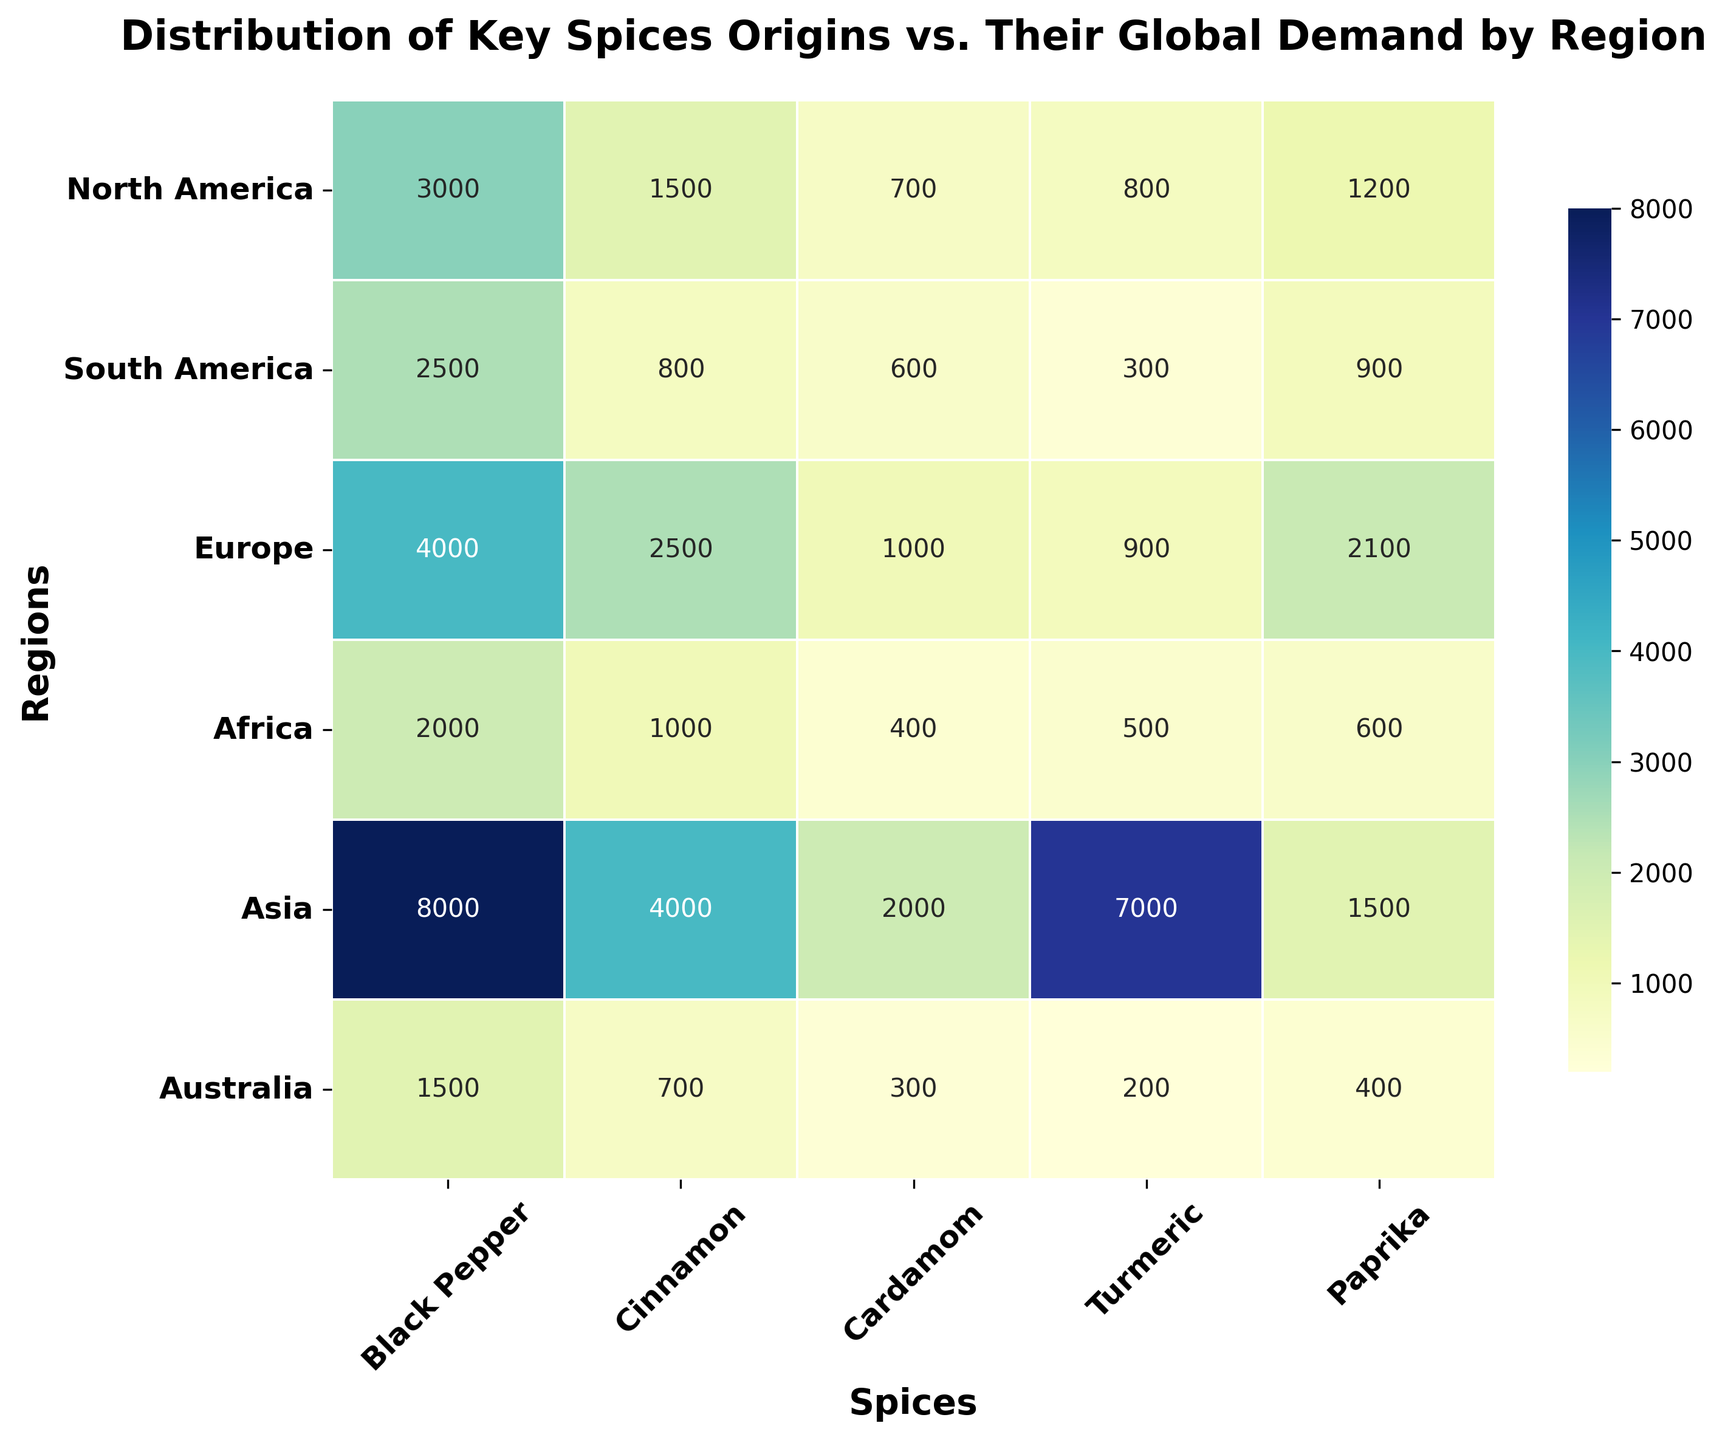which region has the highest global demand for black pepper? By observing the heatmap and looking for the darkest blue (indicating the highest value) in the Black Pepper column, we see that Asia has the darkest blue shade.
Answer: Asia what's the total demand for turmeric in north america and south america combined? Check the values for Turmeric demand in North America and South America: North America = 800, South America = 300. Add the two values: 800 + 300 = 1100.
Answer: 1100 which spice shows the greatest demand in Europe? By examining the Europe row, the highest value is 4000 under Black Pepper. So, Black Pepper shows the greatest demand in Europe.
Answer: Black Pepper compare the demand for cinnamon in asia and europe. which region has higher demand? Check the Cinnamon values for Asia and Europe: Asia = 4000, Europe = 2500. Asia has a higher demand for Cinnamon.
Answer: Asia which regions have a demand for paprika greater than 1000? Look down the Paprika column to find values greater than 1000. The regions are North America (1200) and Europe (2100).
Answer: North America, Europe what's the difference in black pepper demand between europe and africa? Locate the Black Pepper values for Europe and Africa: Europe = 4000, Africa = 2000. Subtract the lower value from the higher value: 4000 - 2000 = 2000.
Answer: 2000 identify the spice with the lowest global demand in south america. Check the South America row, the lowest valued cell is Turmeric with a value of 300.
Answer: Turmeric if you sum the global demand for cardamom across all regions, what total do you get? Add the values for Cardamom across all regions: 700 (North America) + 600 (South America) + 1000 (Europe) + 400 (Africa) + 2000 (Asia) + 300 (Australia) = 5000.
Answer: 5000 average the demand for cinnamon in north america, europe, and australia. Find the Cinnamon values for North America, Europe, and Australia: 1500 (North America), 2500 (Europe), 700 (Australia). Calculate the average: (1500 + 2500 + 700) / 3 = 1533.33.
Answer: 1533.33 